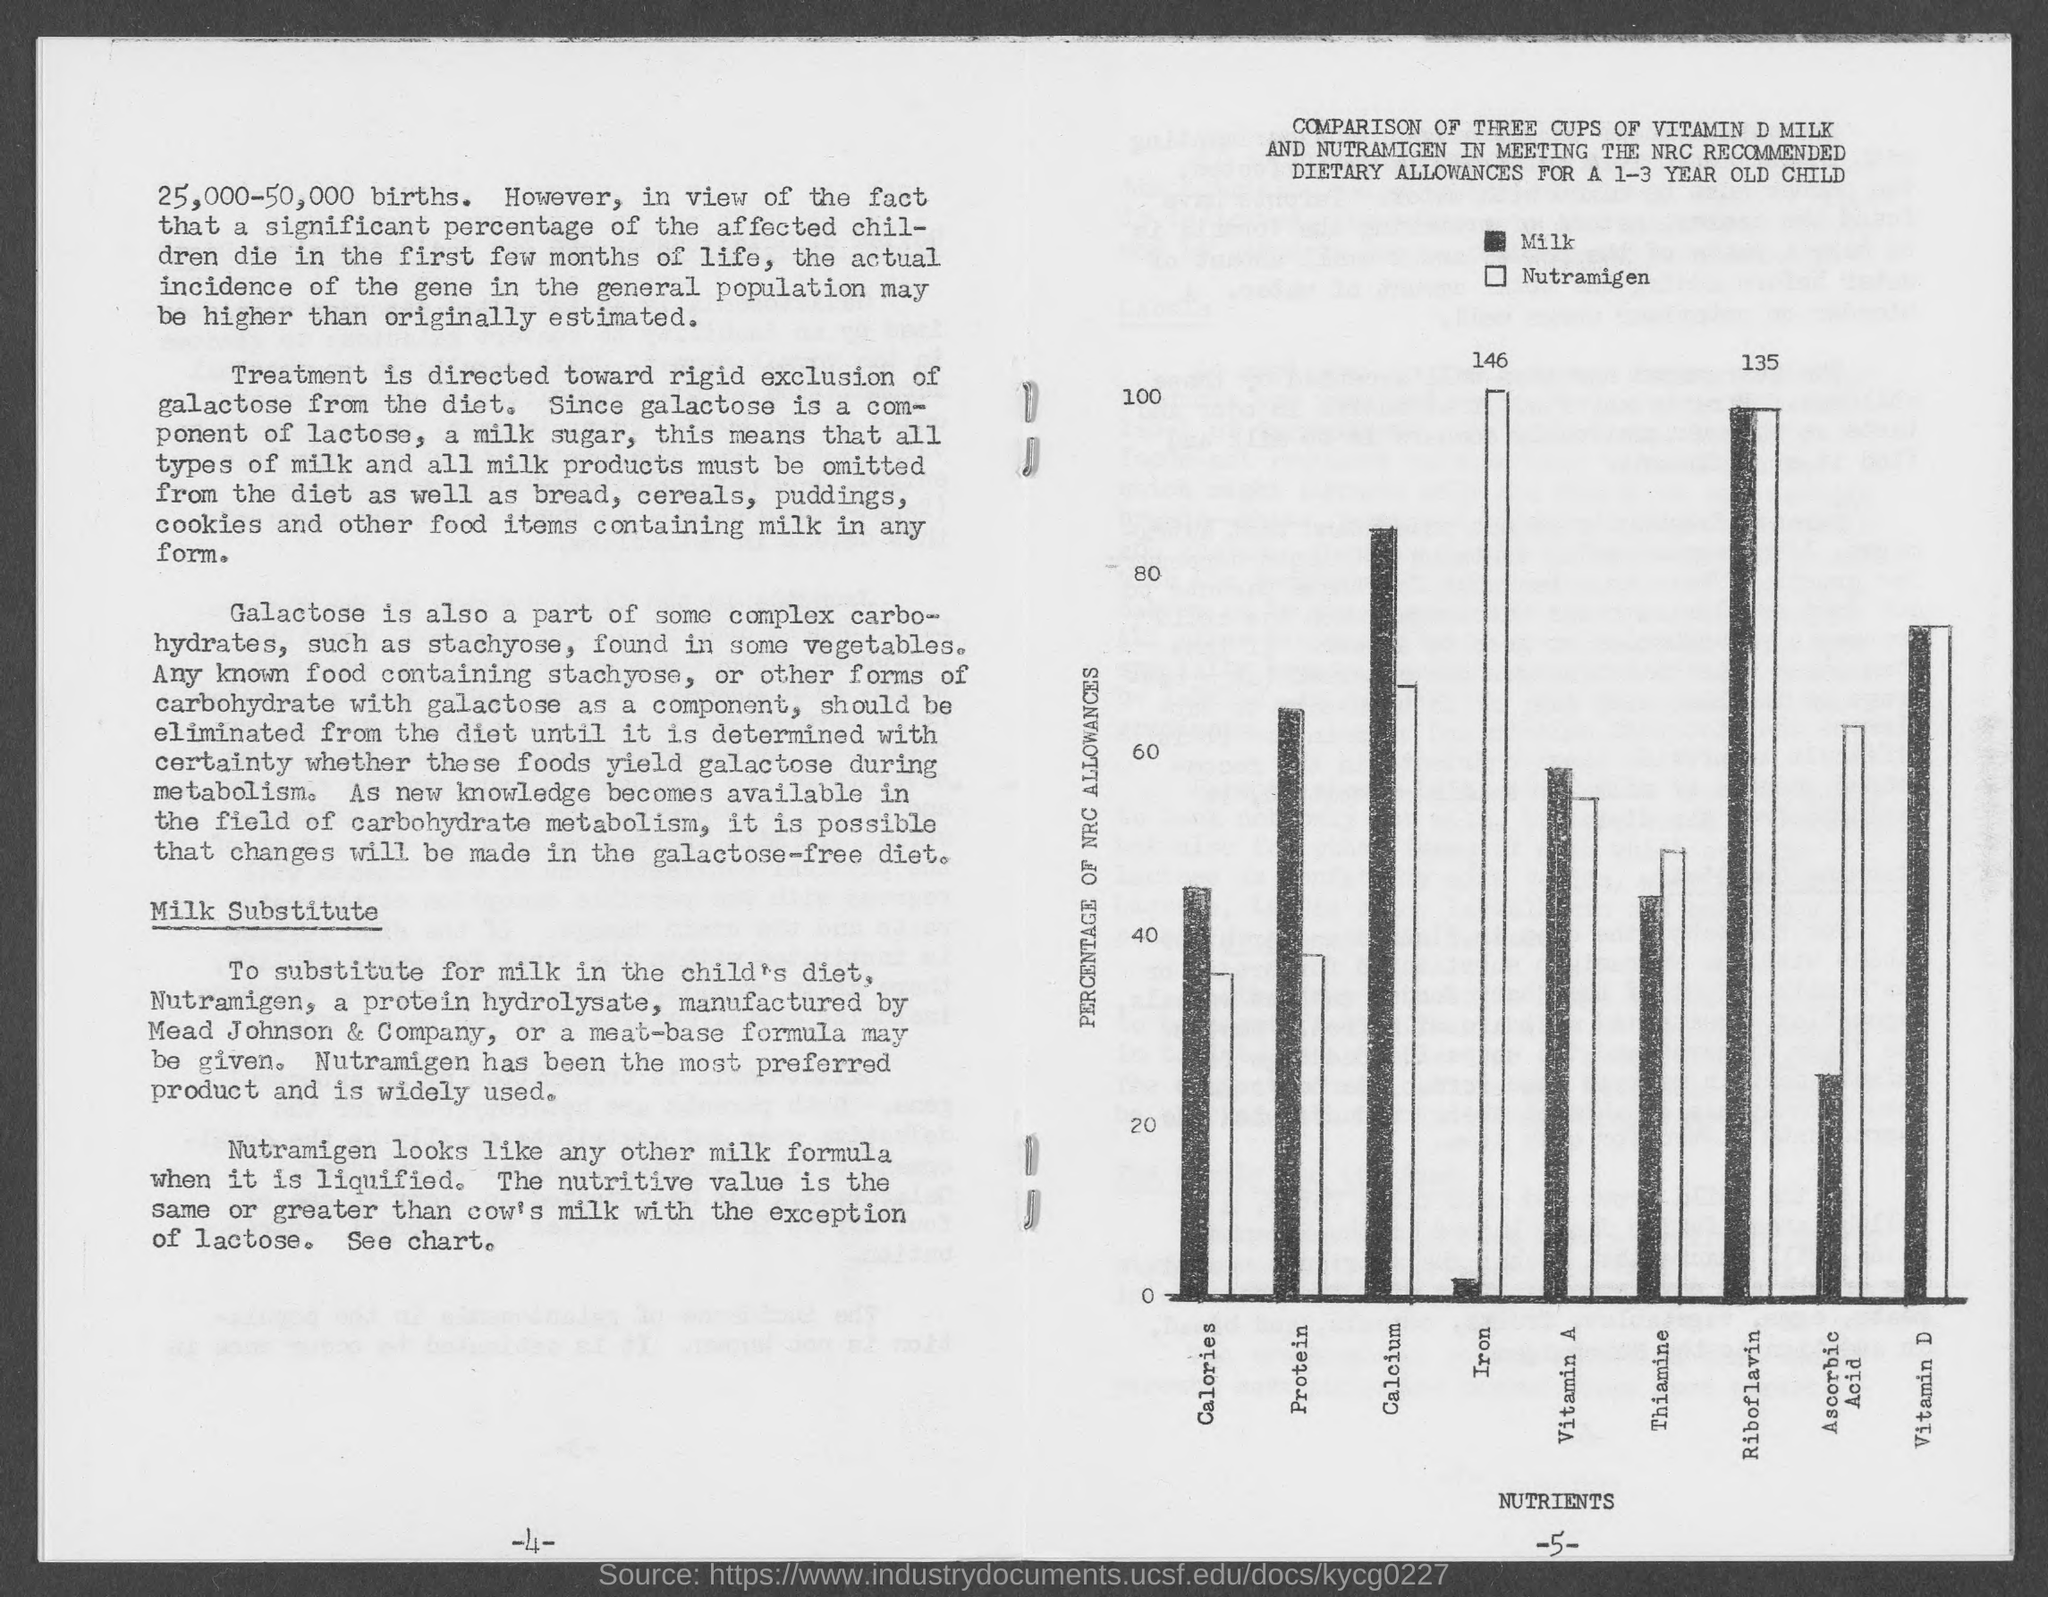Highlight a few significant elements in this photo. It is important to exclude galactose from one's diet as it is rigidly excluded. Nutramigen is a milk formula that, when liquified, appears similar to other milk formulas. The x-axis in the nutrient plot represents the different types of nutrients present in the soil samples. The number of births mentioned is between 25,000 and 50,000 births. Milk has a higher amount of calcium than Nutramigen. 